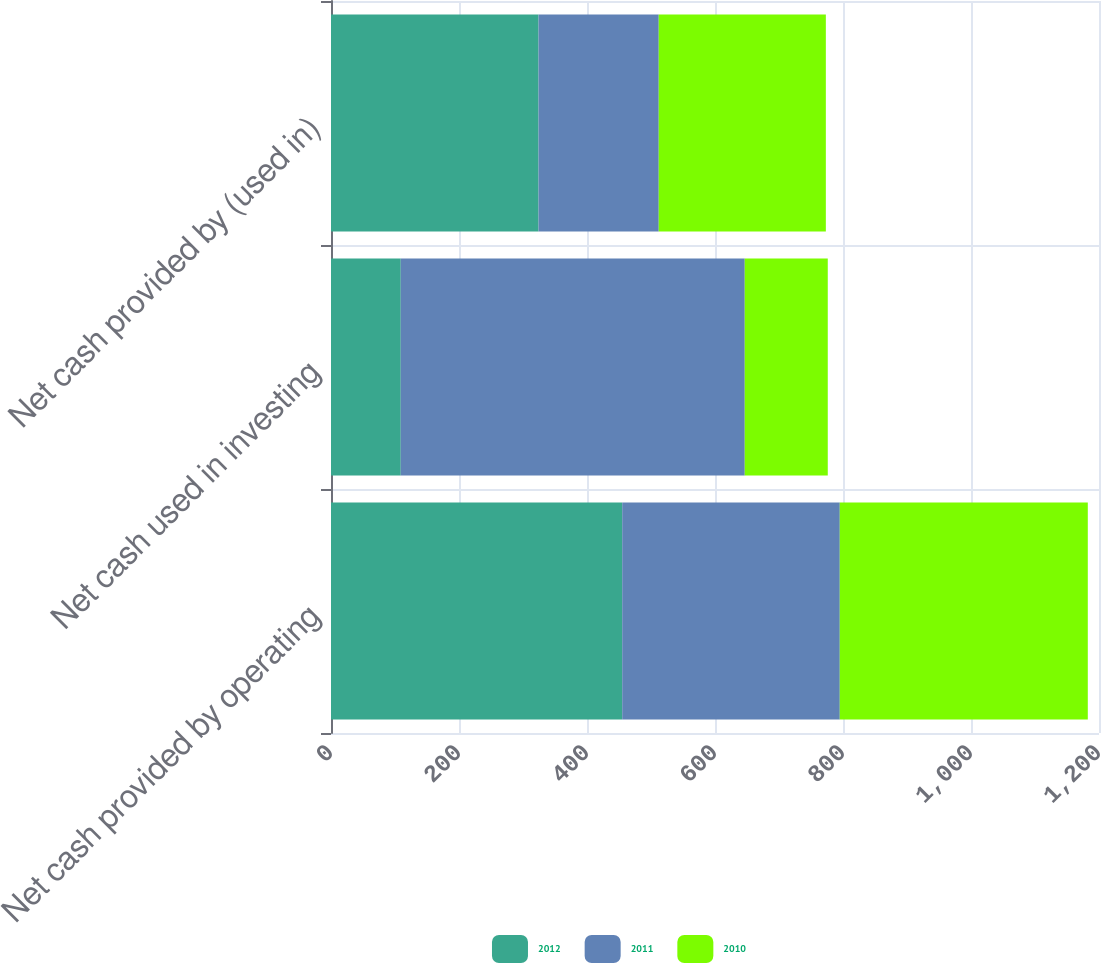Convert chart to OTSL. <chart><loc_0><loc_0><loc_500><loc_500><stacked_bar_chart><ecel><fcel>Net cash provided by operating<fcel>Net cash used in investing<fcel>Net cash provided by (used in)<nl><fcel>2012<fcel>455<fcel>109<fcel>324.3<nl><fcel>2011<fcel>340<fcel>537.5<fcel>187.8<nl><fcel>2010<fcel>387.5<fcel>129.7<fcel>261.1<nl></chart> 